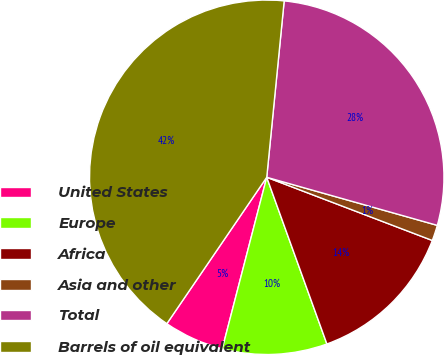Convert chart to OTSL. <chart><loc_0><loc_0><loc_500><loc_500><pie_chart><fcel>United States<fcel>Europe<fcel>Africa<fcel>Asia and other<fcel>Total<fcel>Barrels of oil equivalent<nl><fcel>5.49%<fcel>9.55%<fcel>13.68%<fcel>1.43%<fcel>27.8%<fcel>42.03%<nl></chart> 